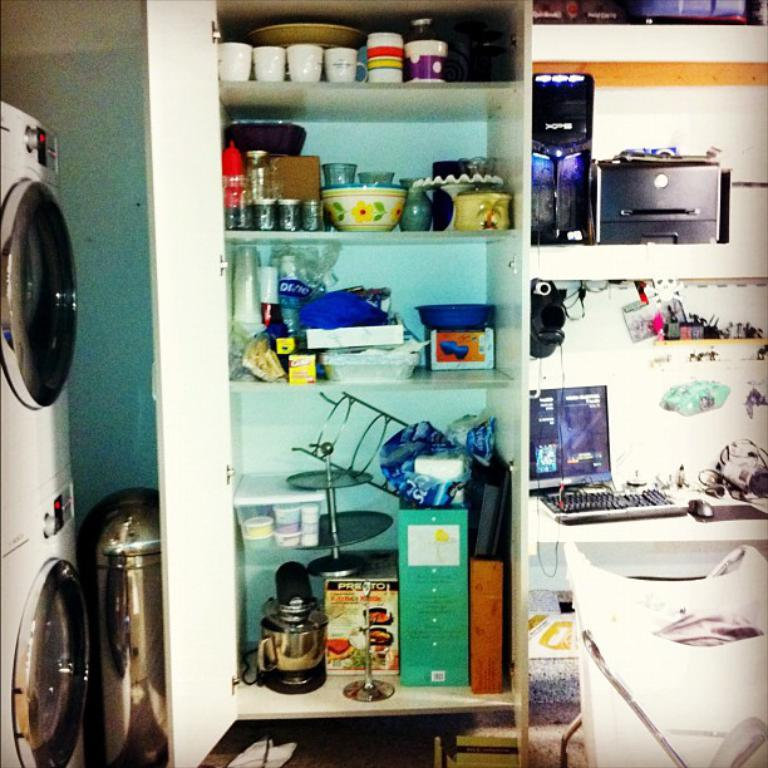What types of containers are visible in the image? There are cups and bottles in the image. What other objects can be seen in the image? There are boxes, racks, a laptop, a keyboard, a mouse, and cables in the image. How many types of electronic devices are present in the image? There are two types of electronic devices in the image: a laptop and a keyboard. What might be used for inputting commands or navigating on the laptop? A mouse is present in the image for inputting commands or navigating on the laptop. Can you see a river flowing under the bridge in the image? There is no river or bridge present in the image; it features electronic devices and containers. 